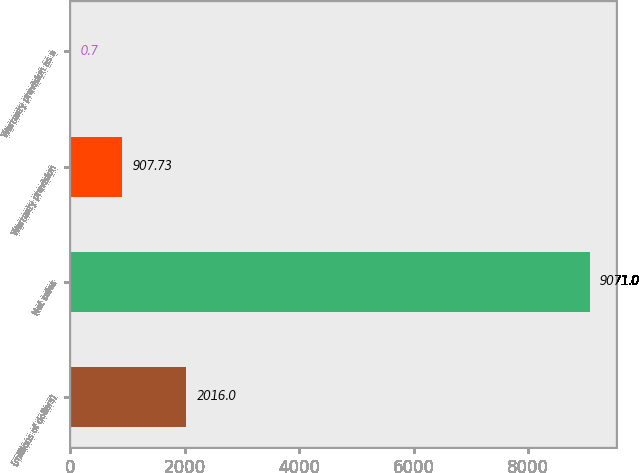Convert chart to OTSL. <chart><loc_0><loc_0><loc_500><loc_500><bar_chart><fcel>(millions of dollars)<fcel>Net sales<fcel>Warranty provision<fcel>Warranty provision as a<nl><fcel>2016<fcel>9071<fcel>907.73<fcel>0.7<nl></chart> 